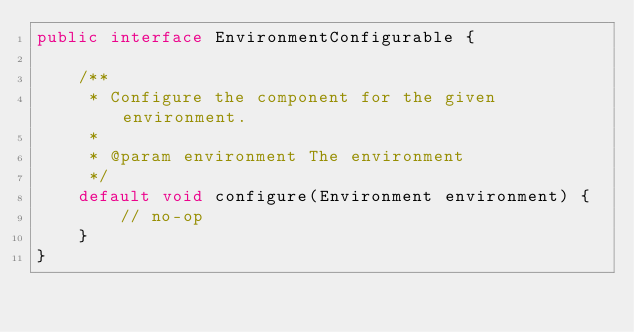Convert code to text. <code><loc_0><loc_0><loc_500><loc_500><_Java_>public interface EnvironmentConfigurable {

    /**
     * Configure the component for the given environment.
     *
     * @param environment The environment
     */
    default void configure(Environment environment) {
        // no-op
    }
}
</code> 